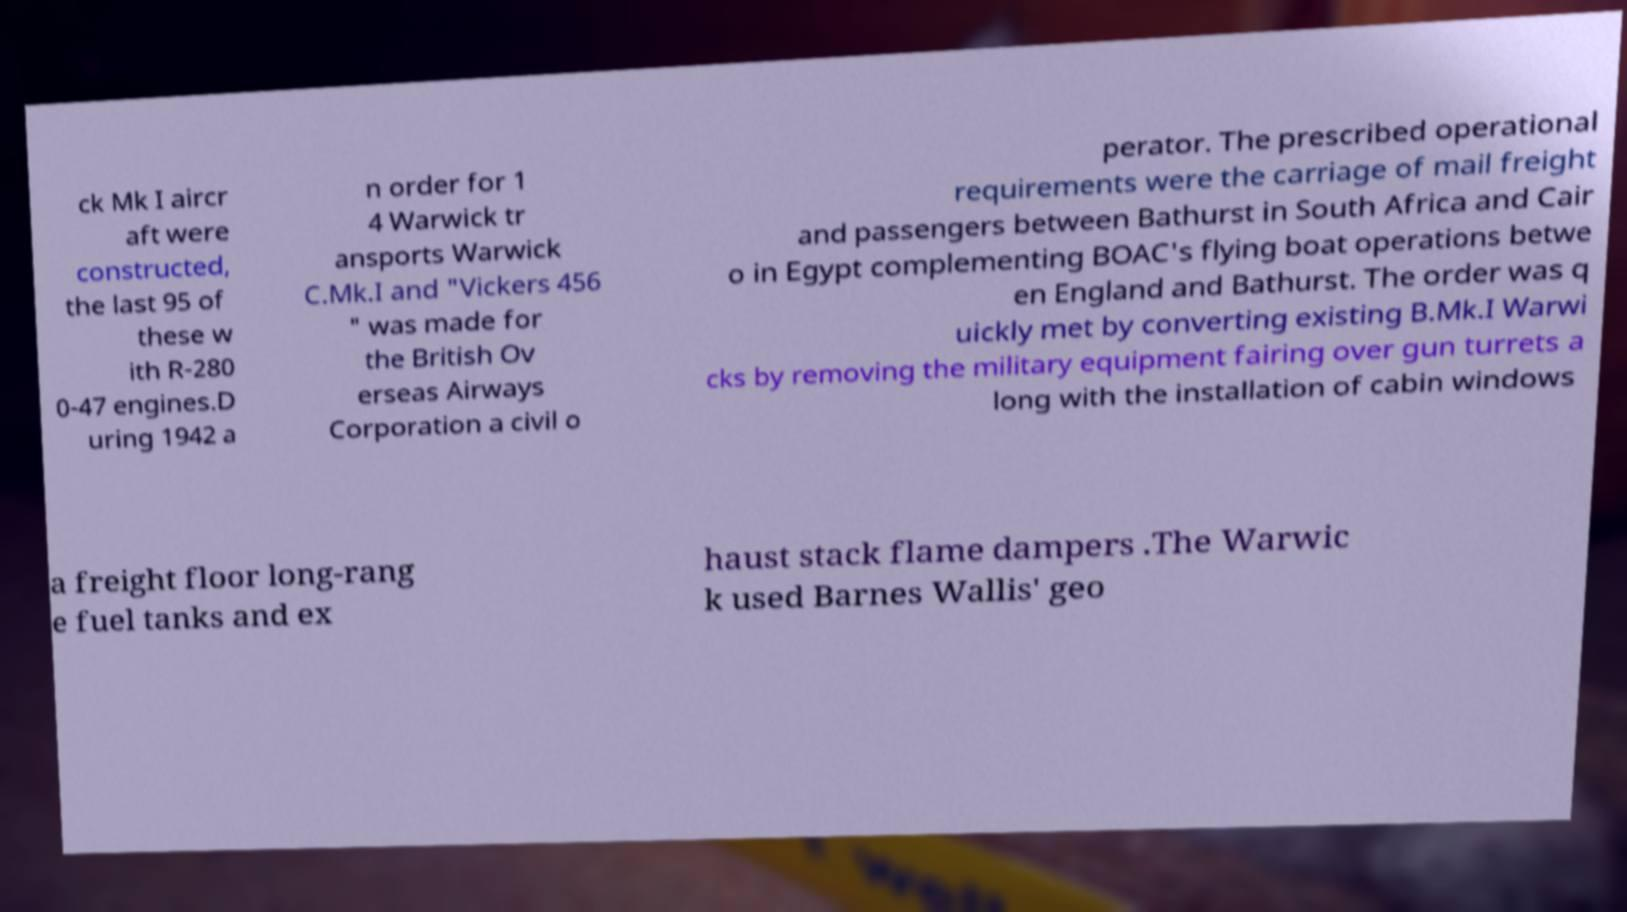Can you read and provide the text displayed in the image?This photo seems to have some interesting text. Can you extract and type it out for me? ck Mk I aircr aft were constructed, the last 95 of these w ith R-280 0-47 engines.D uring 1942 a n order for 1 4 Warwick tr ansports Warwick C.Mk.I and "Vickers 456 " was made for the British Ov erseas Airways Corporation a civil o perator. The prescribed operational requirements were the carriage of mail freight and passengers between Bathurst in South Africa and Cair o in Egypt complementing BOAC's flying boat operations betwe en England and Bathurst. The order was q uickly met by converting existing B.Mk.I Warwi cks by removing the military equipment fairing over gun turrets a long with the installation of cabin windows a freight floor long-rang e fuel tanks and ex haust stack flame dampers .The Warwic k used Barnes Wallis' geo 